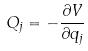<formula> <loc_0><loc_0><loc_500><loc_500>Q _ { j } = - \frac { \partial V } { \partial q _ { j } }</formula> 